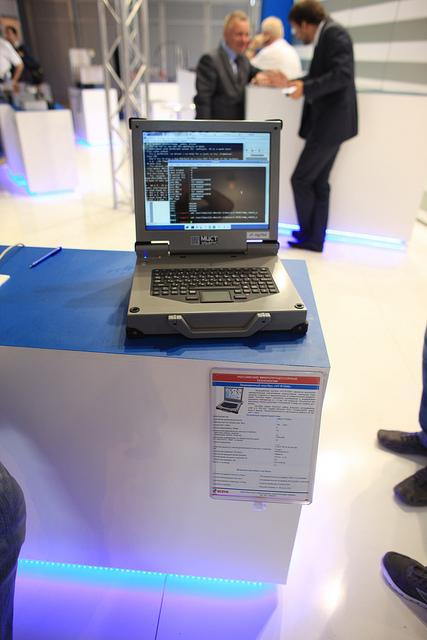Is this a typewriter?
Answer briefly. No. What is the device sitting on?
Answer briefly. Table. What is on the screen?
Write a very short answer. Windows. 